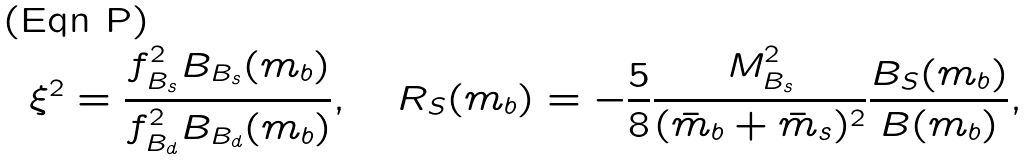<formula> <loc_0><loc_0><loc_500><loc_500>\xi ^ { 2 } = \frac { f _ { B _ { s } } ^ { 2 } B _ { B _ { s } } ( m _ { b } ) } { f _ { B _ { d } } ^ { 2 } B _ { B _ { d } } ( m _ { b } ) } , \quad R _ { S } ( m _ { b } ) = - \frac { 5 } { 8 } \frac { M _ { B _ { s } } ^ { 2 } } { ( \bar { m } _ { b } + \bar { m } _ { s } ) ^ { 2 } } \frac { B _ { S } ( m _ { b } ) } { B ( m _ { b } ) } ,</formula> 